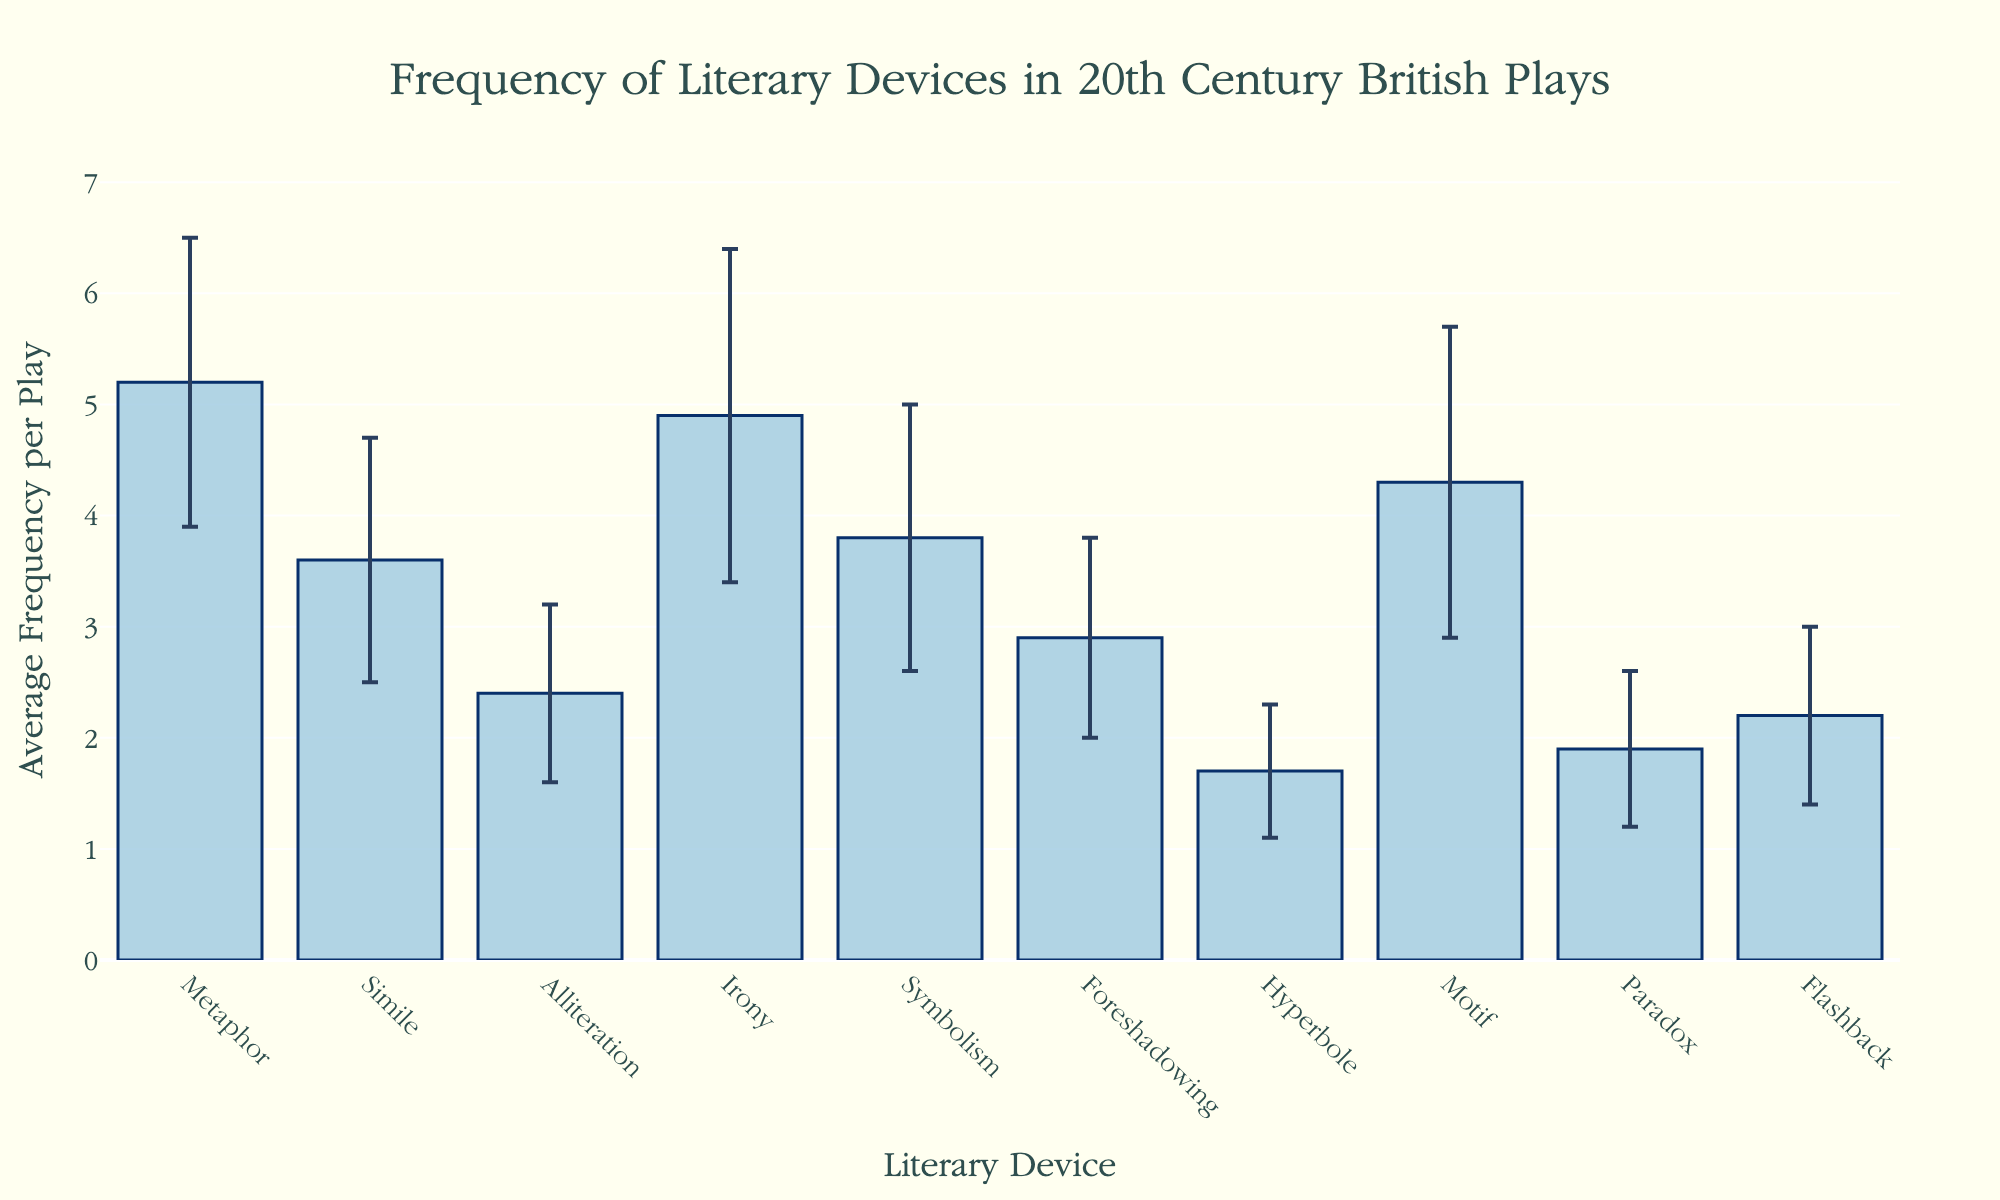What is the title of the plot? The title is at the top of the figure and describes the content of the plot.
Answer: Frequency of Literary Devices in 20th Century British Plays What does the y-axis represent? The y-axis title is given on the vertical axis and indicates what is being measured.
Answer: Average Frequency per Play Which literary device has the highest average frequency per play? By looking at the height of the bars, you can determine which one is the tallest.
Answer: Metaphor Which two literary devices have the closest average frequencies per play? Compare the heights of the bars. Metaphor and Irony and Symbolism are fairly close but check another pair for more accuracy.
Answer: Irony and Motif What is the average frequency of Simile per play? Find the bar labeled 'Simile' and check the height corresponding to its frequency on the y-axis.
Answer: 3.6 What is the standard deviation for Foreshadowing? The standard deviation is depicted by the error bars extending above and below the average frequency. Look at the bar labeled 'Foreshadowing.'
Answer: 0.9 Can you name the literary devices with a standard deviation greater than 1.2? Identify the bars with error bars extending more than 1.2 units. Metaphor, Irony, and Motif meet this criterion.
Answer: Metaphor, Irony, Motif Which literary device has the lowest average frequency per play? The shortest bar corresponds to the device with the lowest average frequency.
Answer: Hyperbole How much greater is the average frequency of Metaphor compared to Hyperbole? Subtract the average frequency of Hyperbole from the average frequency of Metaphor (5.2 - 1.7).
Answer: 3.5 What is the combined average frequency of Alliteration, Flashback, and Paradox? Add the average frequencies from the bars labeled 'Alliteration,' 'Flashback,' and 'Paradox' (2.4 + 2.2 + 1.9).
Answer: 6.5 